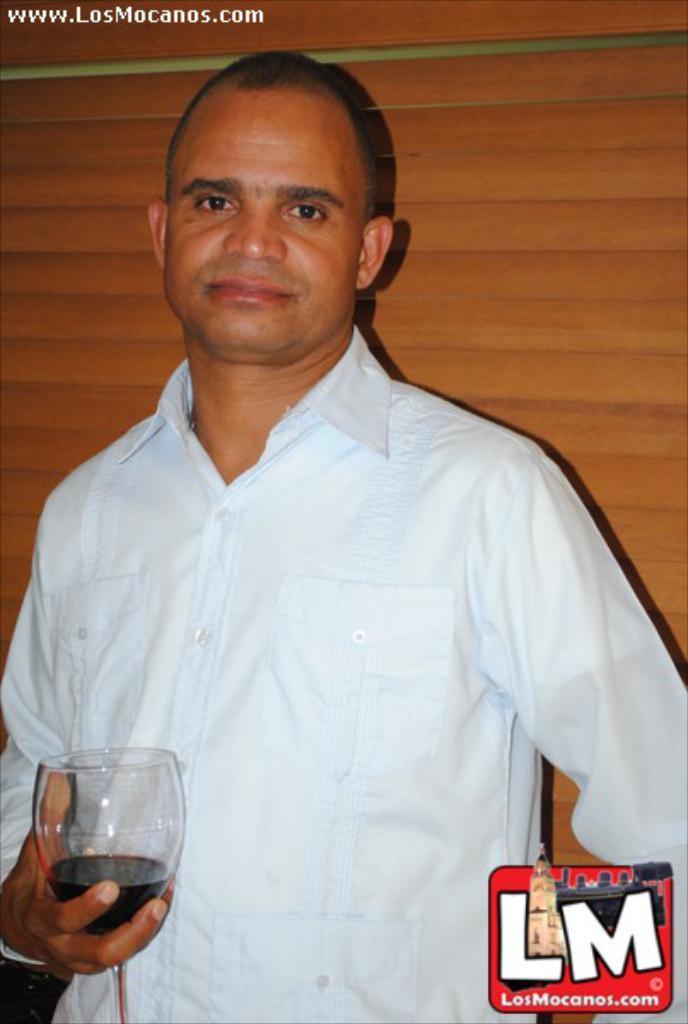How would you summarize this image in a sentence or two? This image consists of a man who is holding a glass in the bottom left corner. There is a logo LM. This man is wearing sky blue color shirt. 